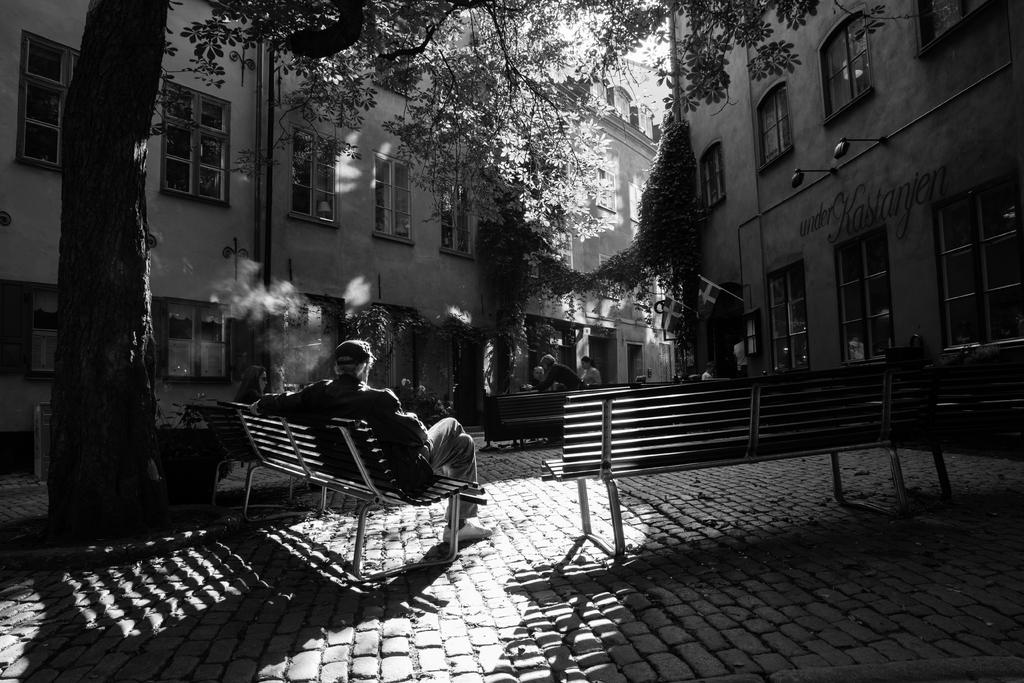What is the man in the image doing? The man is sitting in a chair. Where is the chair located in the image? The chair is on the left side of the image. What can be seen behind the chair? There is a tree behind the chair. What type of structure is visible in the image? There is a building in the image. What type of cord is the man holding in the image? There is no cord present in the image; the man is simply sitting in a chair. 